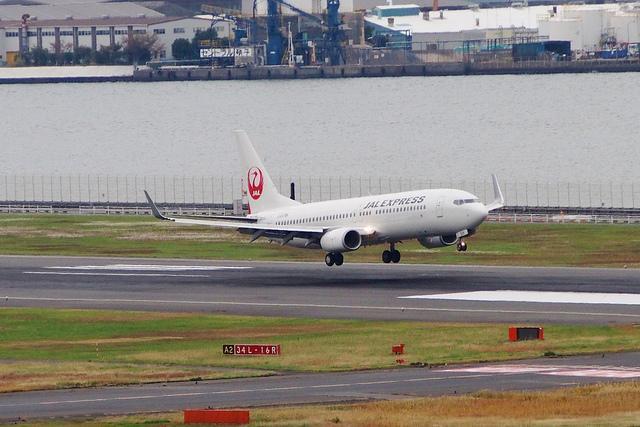In which country is this airport located?
Choose the right answer from the provided options to respond to the question.
Options: Korea, japan, india, china. Japan. 